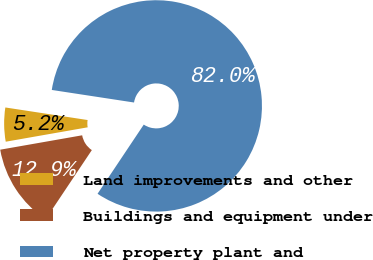<chart> <loc_0><loc_0><loc_500><loc_500><pie_chart><fcel>Land improvements and other<fcel>Buildings and equipment under<fcel>Net property plant and<nl><fcel>5.18%<fcel>12.86%<fcel>81.97%<nl></chart> 